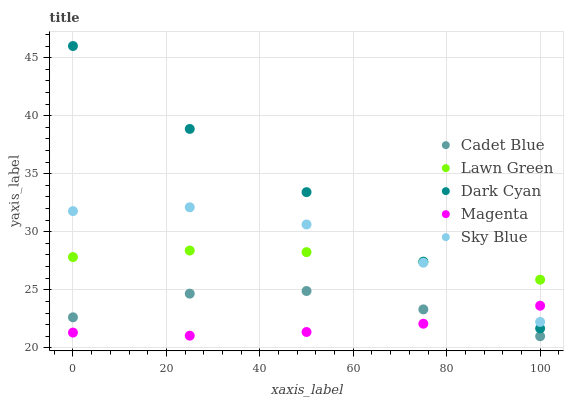Does Magenta have the minimum area under the curve?
Answer yes or no. Yes. Does Dark Cyan have the maximum area under the curve?
Answer yes or no. Yes. Does Lawn Green have the minimum area under the curve?
Answer yes or no. No. Does Lawn Green have the maximum area under the curve?
Answer yes or no. No. Is Magenta the smoothest?
Answer yes or no. Yes. Is Sky Blue the roughest?
Answer yes or no. Yes. Is Lawn Green the smoothest?
Answer yes or no. No. Is Lawn Green the roughest?
Answer yes or no. No. Does Cadet Blue have the lowest value?
Answer yes or no. Yes. Does Magenta have the lowest value?
Answer yes or no. No. Does Dark Cyan have the highest value?
Answer yes or no. Yes. Does Lawn Green have the highest value?
Answer yes or no. No. Is Cadet Blue less than Lawn Green?
Answer yes or no. Yes. Is Lawn Green greater than Magenta?
Answer yes or no. Yes. Does Magenta intersect Sky Blue?
Answer yes or no. Yes. Is Magenta less than Sky Blue?
Answer yes or no. No. Is Magenta greater than Sky Blue?
Answer yes or no. No. Does Cadet Blue intersect Lawn Green?
Answer yes or no. No. 